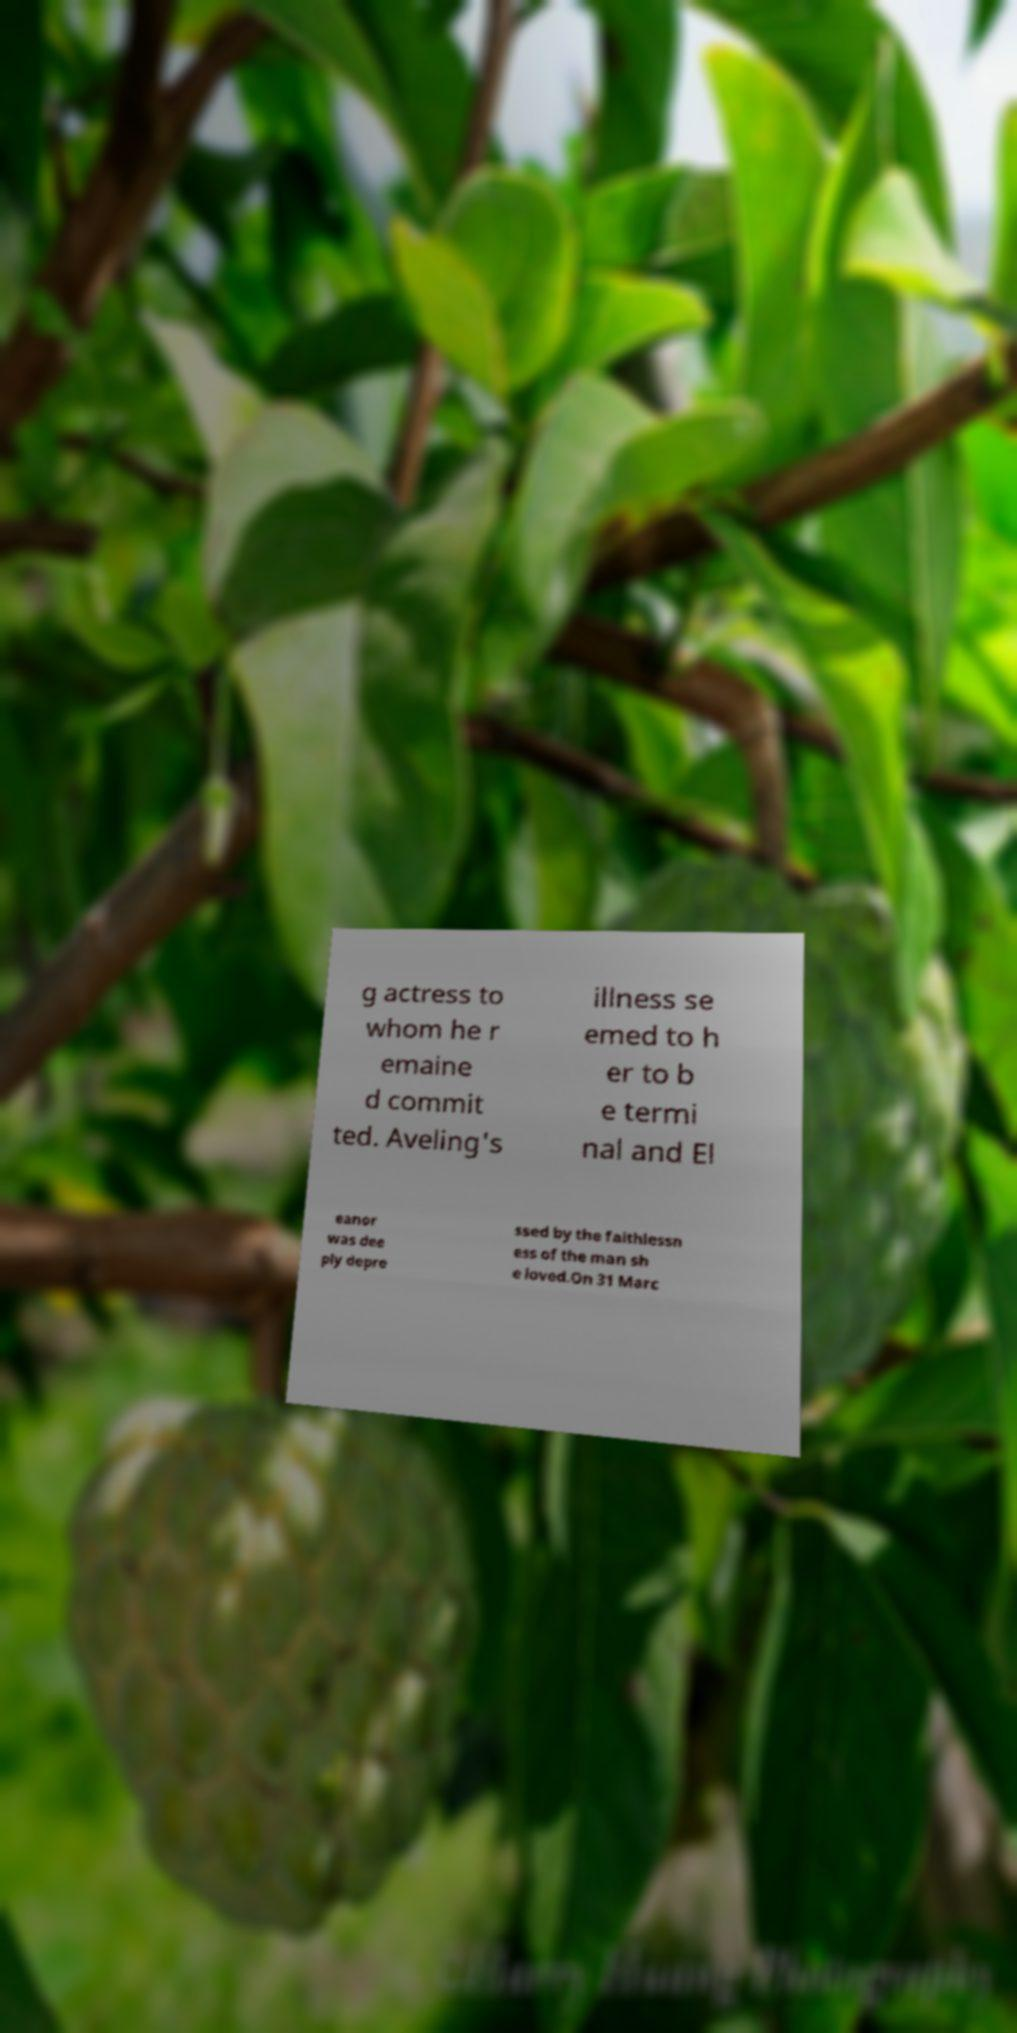Could you assist in decoding the text presented in this image and type it out clearly? g actress to whom he r emaine d commit ted. Aveling's illness se emed to h er to b e termi nal and El eanor was dee ply depre ssed by the faithlessn ess of the man sh e loved.On 31 Marc 